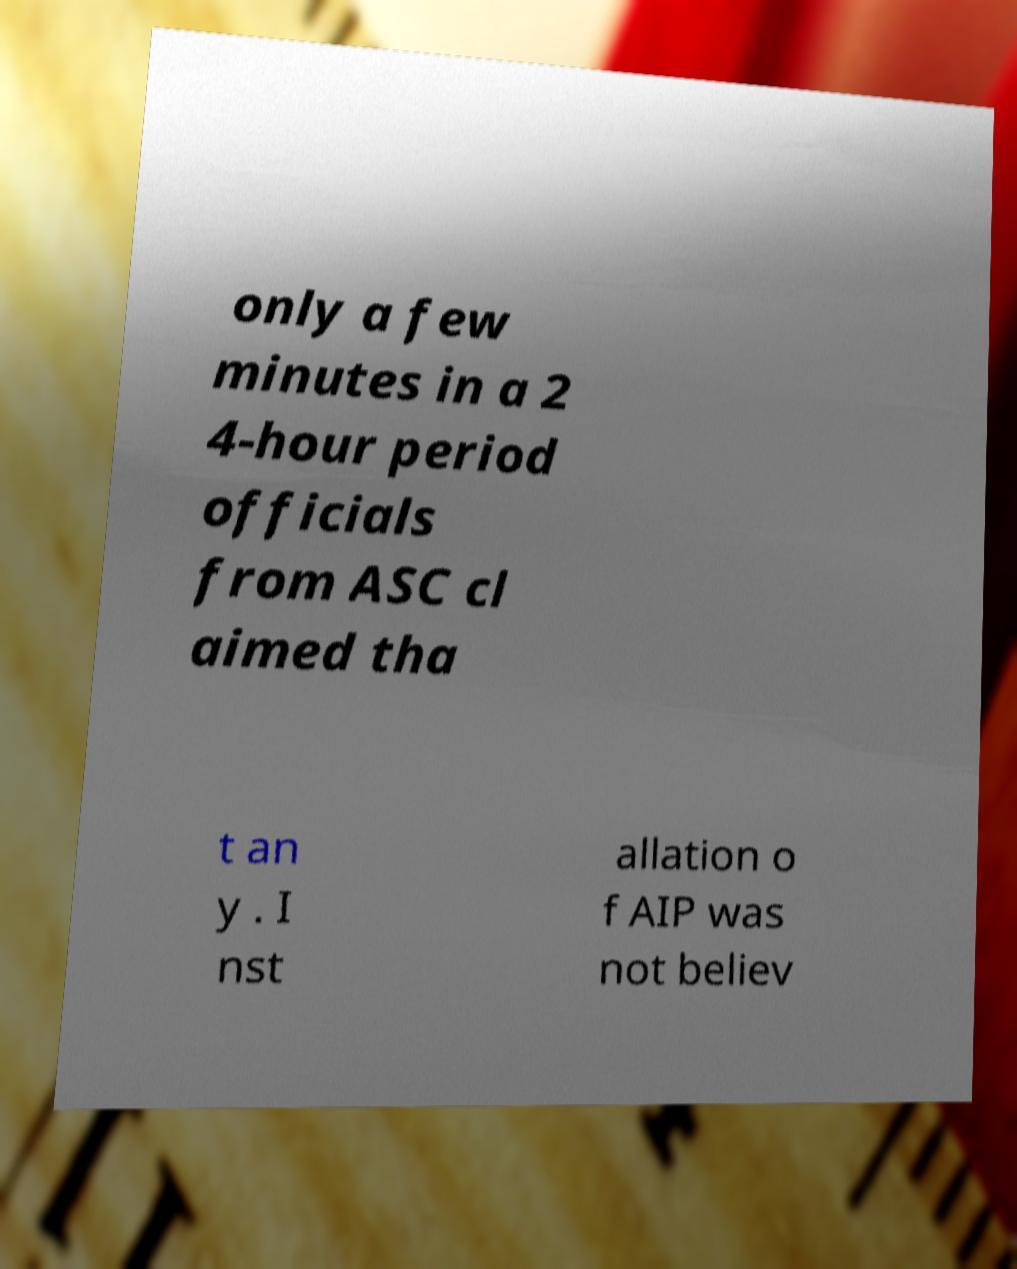Please identify and transcribe the text found in this image. only a few minutes in a 2 4-hour period officials from ASC cl aimed tha t an y . I nst allation o f AIP was not believ 